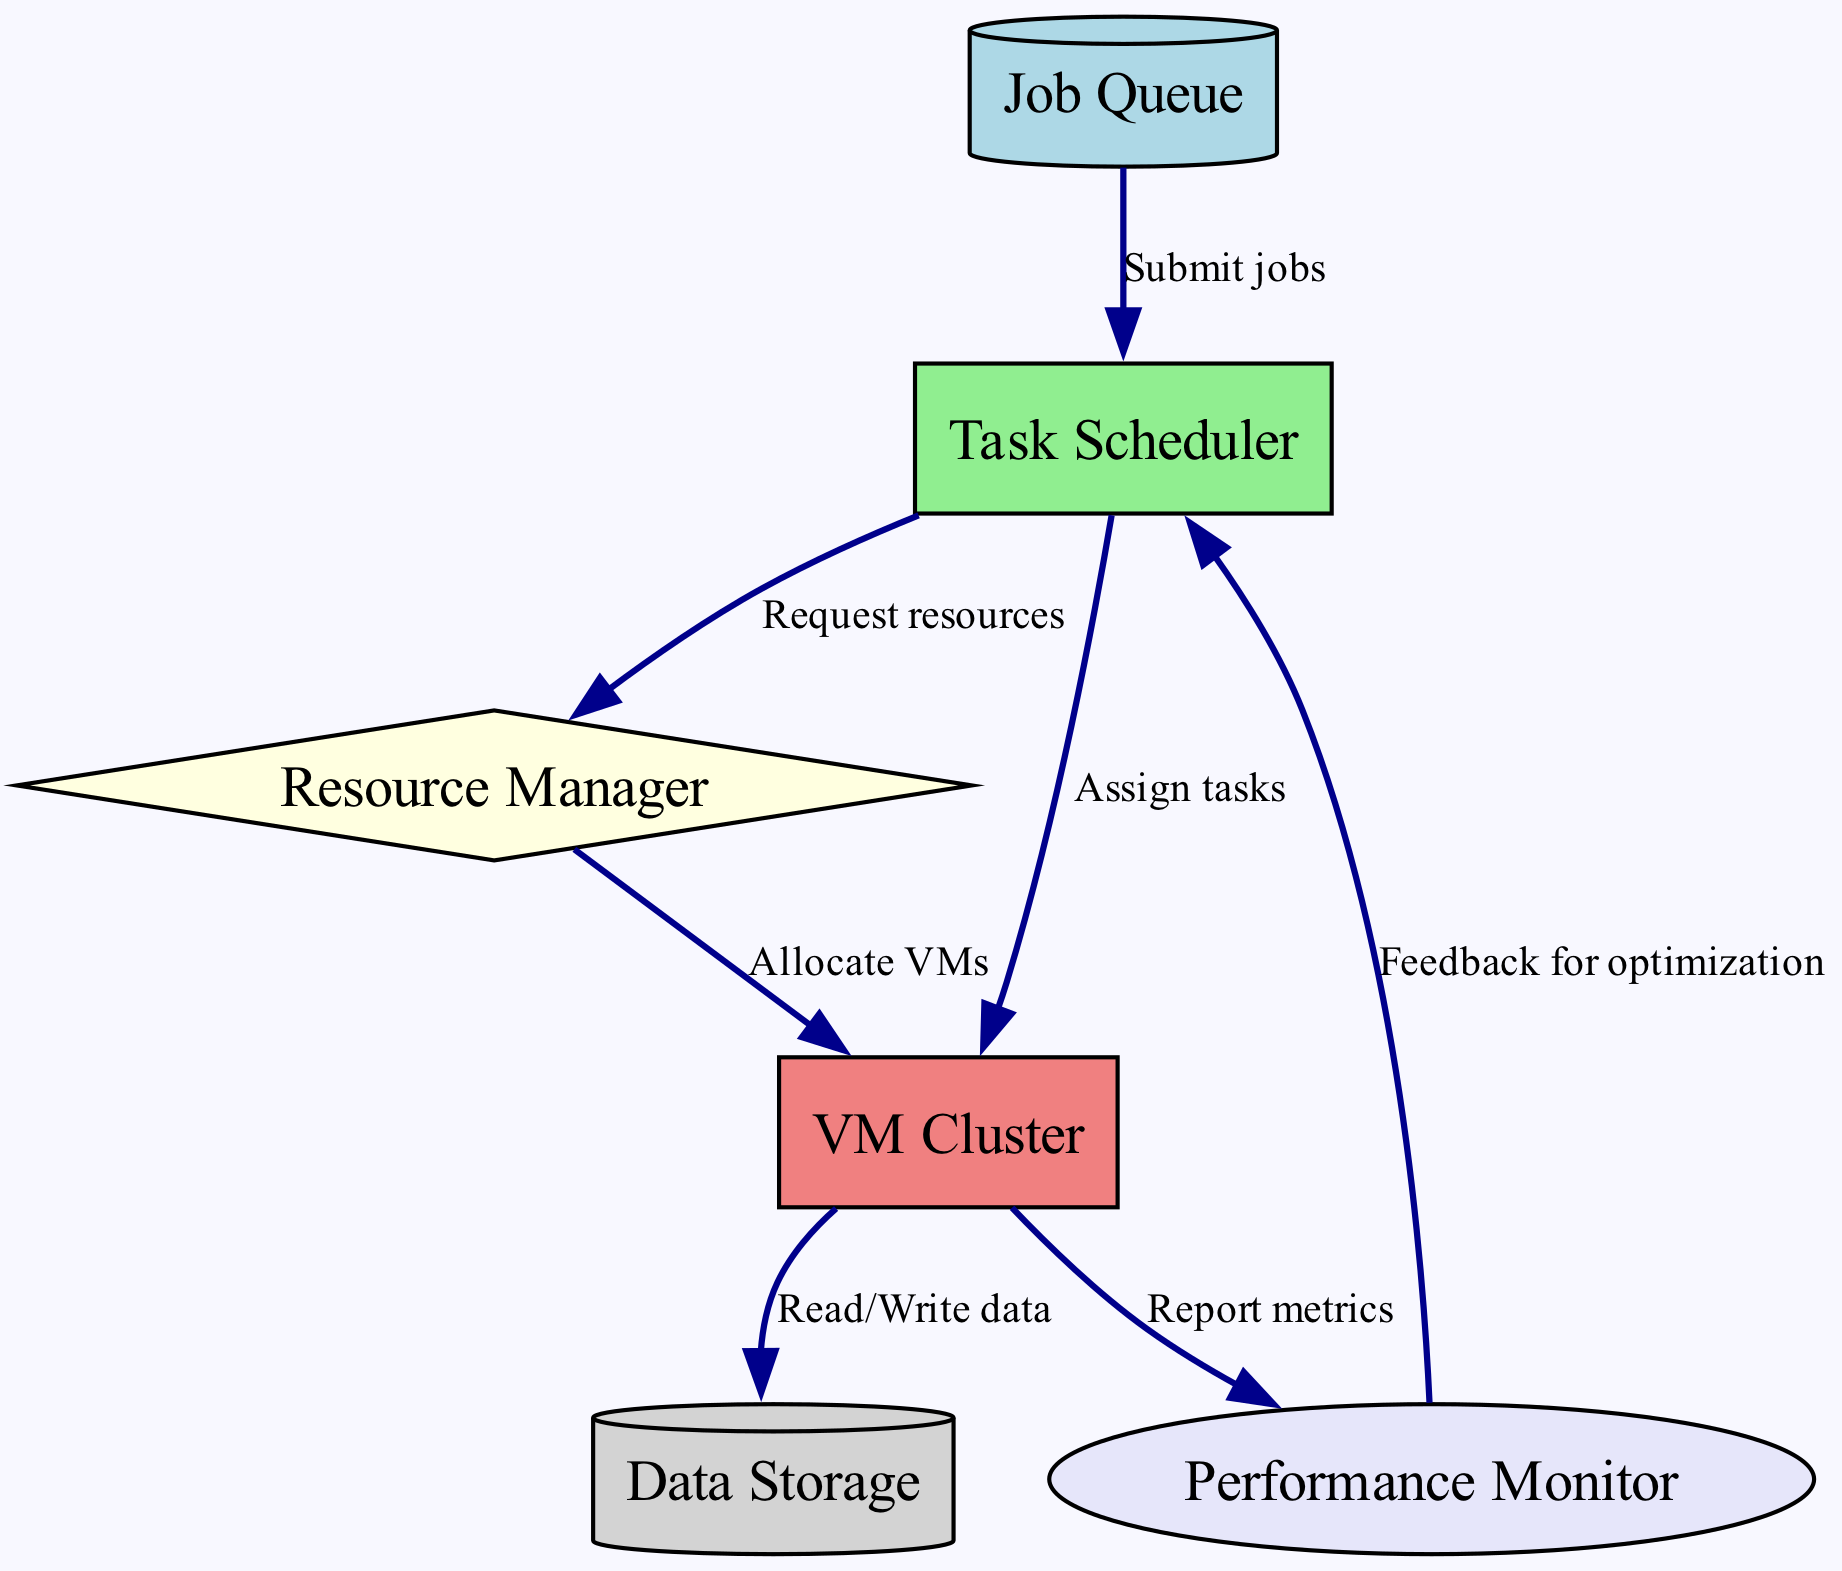What is the starting point for job processing in this diagram? The starting point for job processing is represented by the "Job Queue," which is the first node where jobs are submitted before being processed.
Answer: Job Queue How many nodes are present in the diagram? Counting each node in the diagram, we find there are six distinct nodes: Job Queue, Task Scheduler, Resource Manager, VM Cluster, Data Storage, and Performance Monitor.
Answer: Six What type of connection is made from the Task Scheduler to the Resource Manager? The connection from the Task Scheduler to the Resource Manager is labeled "Request resources," indicating that the Task Scheduler requests resources from the Resource Manager.
Answer: Request resources Which node is responsible for reporting performance metrics? The node responsible for reporting performance metrics is the "Performance Monitor," which receives data from the VM Cluster to ensure the system runs optimally.
Answer: Performance Monitor What happens after the Resource Manager allocates VMs? After the Resource Manager allocates VMs, it proceeds to assign tasks from the Task Scheduler to the VM Cluster, allowing tasks to execute on the allocated resources.
Answer: Assign tasks How does the Performance Monitor contribute to optimization? The Performance Monitor contributes to optimization by providing feedback to the Task Scheduler, which allows it to adjust scheduling and resource allocation based on real-time performance data.
Answer: Feedback for optimization What is the relationship between the VM Cluster and Data Storage? The relationship between the VM Cluster and Data Storage is defined by the ability of the VM Cluster to Read/Write data, indicating interaction needed for tasks that require data access.
Answer: Read/Write data Which node does the Job Queue send jobs to? The Job Queue sends jobs to the Task Scheduler, which is the next step in the workflow after jobs are submitted.
Answer: Task Scheduler What type of processes does the Task Scheduler manage? The Task Scheduler primarily manages task assignments, directing which tasks to execute on the VM Cluster based on available resources and job submissions.
Answer: Manage task assignments 